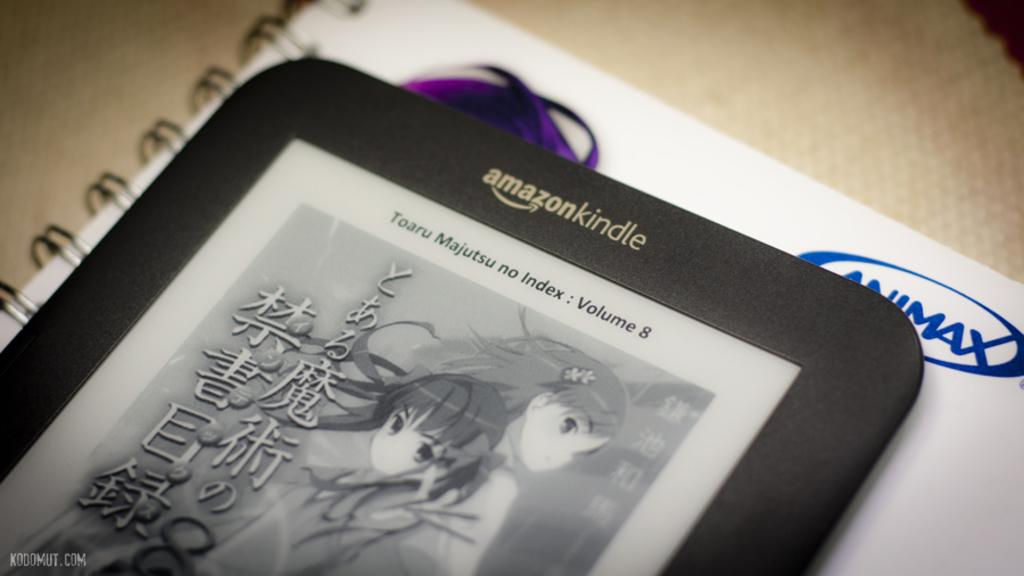Provide a one-sentence caption for the provided image. an Amazon kindle is on the white paper. 